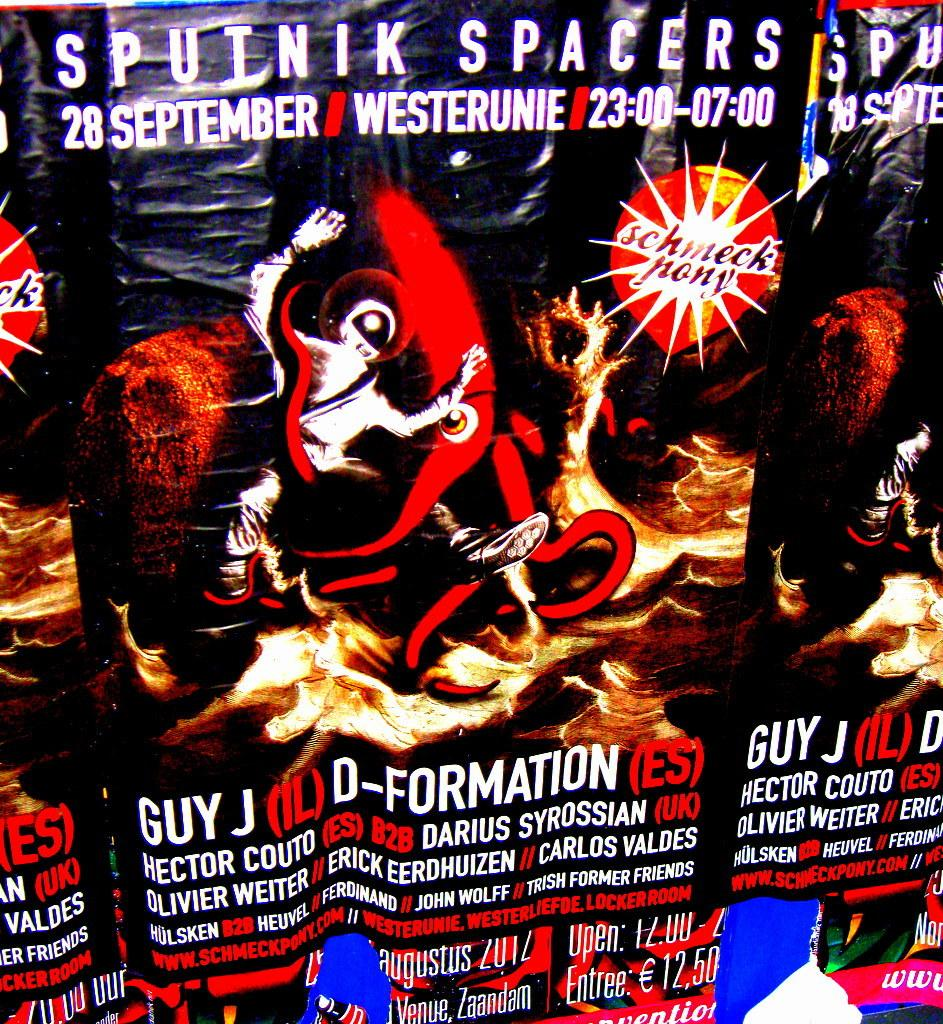<image>
Relay a brief, clear account of the picture shown. A poster for a rave on the 28th Spetember in Germany tells us Guy J, D-formation and many others will be taking part. 